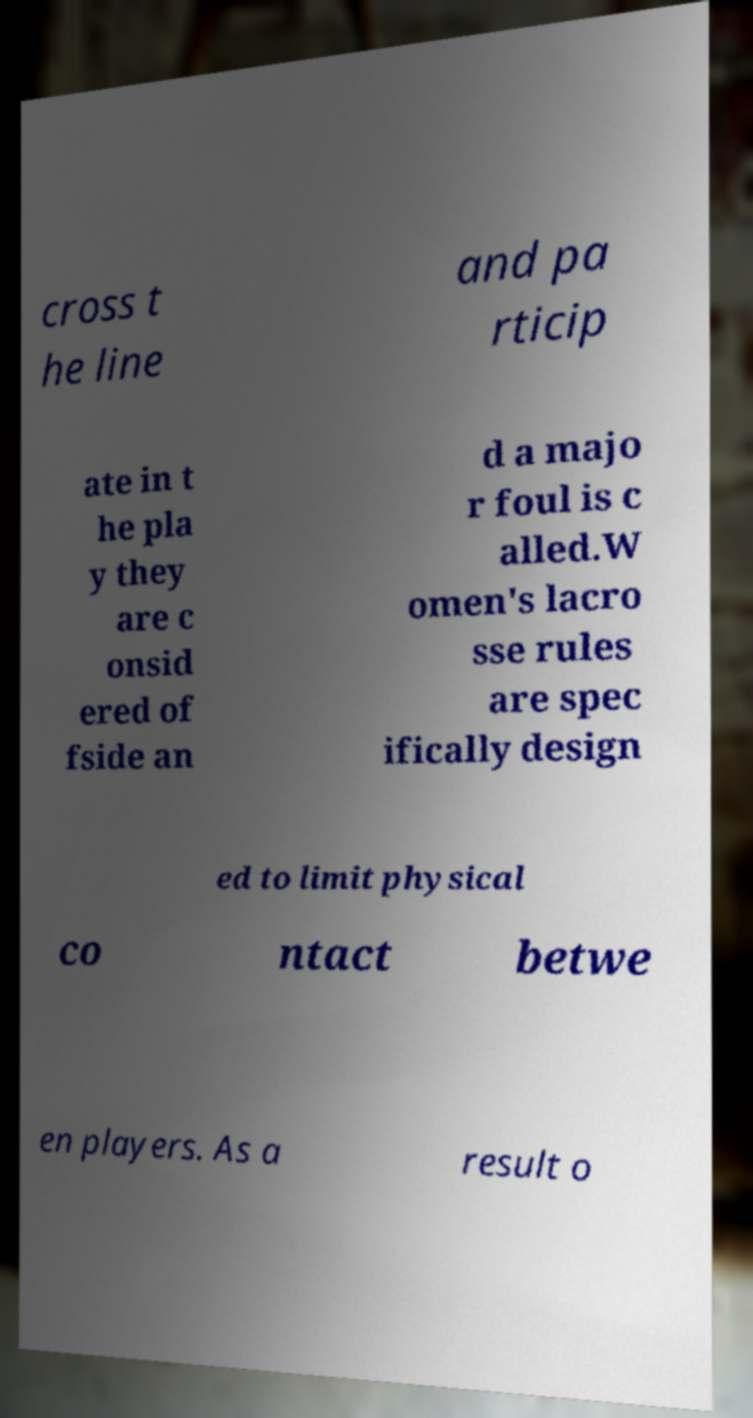There's text embedded in this image that I need extracted. Can you transcribe it verbatim? cross t he line and pa rticip ate in t he pla y they are c onsid ered of fside an d a majo r foul is c alled.W omen's lacro sse rules are spec ifically design ed to limit physical co ntact betwe en players. As a result o 